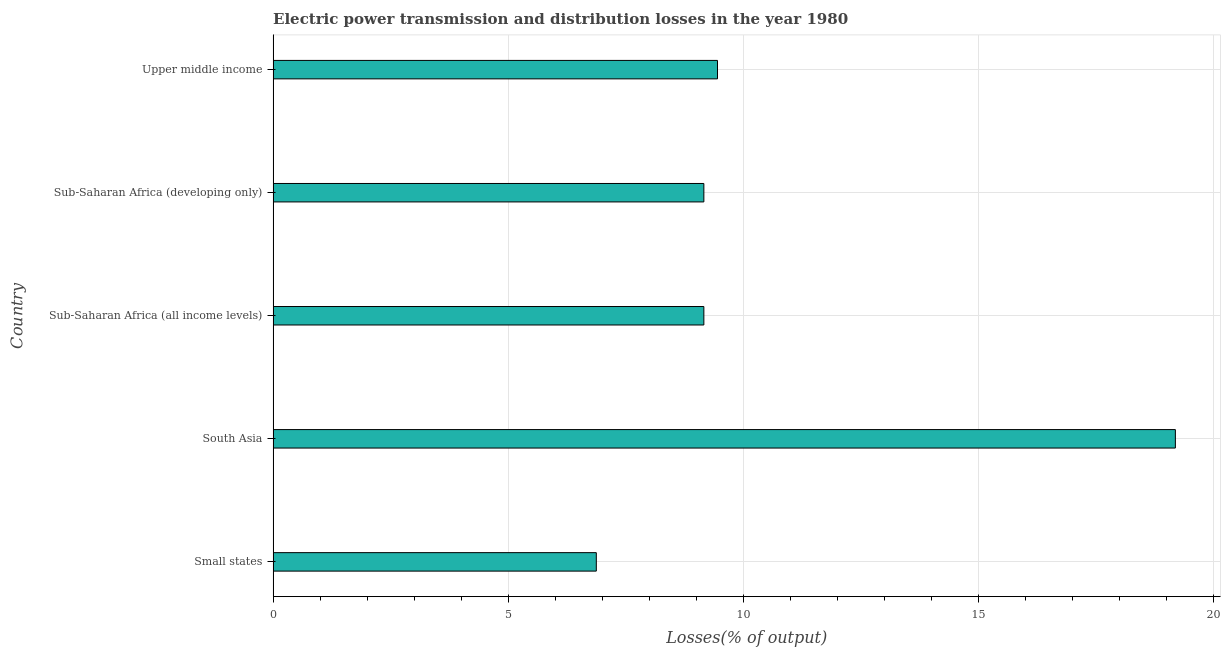Does the graph contain grids?
Ensure brevity in your answer.  Yes. What is the title of the graph?
Offer a terse response. Electric power transmission and distribution losses in the year 1980. What is the label or title of the X-axis?
Ensure brevity in your answer.  Losses(% of output). What is the label or title of the Y-axis?
Provide a succinct answer. Country. What is the electric power transmission and distribution losses in South Asia?
Ensure brevity in your answer.  19.19. Across all countries, what is the maximum electric power transmission and distribution losses?
Your answer should be compact. 19.19. Across all countries, what is the minimum electric power transmission and distribution losses?
Your answer should be compact. 6.88. In which country was the electric power transmission and distribution losses minimum?
Keep it short and to the point. Small states. What is the sum of the electric power transmission and distribution losses?
Keep it short and to the point. 53.85. What is the difference between the electric power transmission and distribution losses in Sub-Saharan Africa (developing only) and Upper middle income?
Ensure brevity in your answer.  -0.29. What is the average electric power transmission and distribution losses per country?
Provide a short and direct response. 10.77. What is the median electric power transmission and distribution losses?
Your answer should be very brief. 9.16. What is the difference between the highest and the second highest electric power transmission and distribution losses?
Your answer should be compact. 9.74. Is the sum of the electric power transmission and distribution losses in Small states and Sub-Saharan Africa (developing only) greater than the maximum electric power transmission and distribution losses across all countries?
Provide a succinct answer. No. What is the difference between the highest and the lowest electric power transmission and distribution losses?
Provide a short and direct response. 12.32. What is the Losses(% of output) in Small states?
Your answer should be compact. 6.88. What is the Losses(% of output) in South Asia?
Ensure brevity in your answer.  19.19. What is the Losses(% of output) of Sub-Saharan Africa (all income levels)?
Provide a short and direct response. 9.16. What is the Losses(% of output) of Sub-Saharan Africa (developing only)?
Your response must be concise. 9.16. What is the Losses(% of output) of Upper middle income?
Your answer should be very brief. 9.45. What is the difference between the Losses(% of output) in Small states and South Asia?
Your answer should be very brief. -12.32. What is the difference between the Losses(% of output) in Small states and Sub-Saharan Africa (all income levels)?
Your response must be concise. -2.29. What is the difference between the Losses(% of output) in Small states and Sub-Saharan Africa (developing only)?
Provide a short and direct response. -2.29. What is the difference between the Losses(% of output) in Small states and Upper middle income?
Your answer should be very brief. -2.58. What is the difference between the Losses(% of output) in South Asia and Sub-Saharan Africa (all income levels)?
Offer a terse response. 10.03. What is the difference between the Losses(% of output) in South Asia and Sub-Saharan Africa (developing only)?
Keep it short and to the point. 10.03. What is the difference between the Losses(% of output) in South Asia and Upper middle income?
Provide a short and direct response. 9.74. What is the difference between the Losses(% of output) in Sub-Saharan Africa (all income levels) and Sub-Saharan Africa (developing only)?
Ensure brevity in your answer.  0. What is the difference between the Losses(% of output) in Sub-Saharan Africa (all income levels) and Upper middle income?
Keep it short and to the point. -0.29. What is the difference between the Losses(% of output) in Sub-Saharan Africa (developing only) and Upper middle income?
Make the answer very short. -0.29. What is the ratio of the Losses(% of output) in Small states to that in South Asia?
Give a very brief answer. 0.36. What is the ratio of the Losses(% of output) in Small states to that in Sub-Saharan Africa (all income levels)?
Keep it short and to the point. 0.75. What is the ratio of the Losses(% of output) in Small states to that in Upper middle income?
Provide a succinct answer. 0.73. What is the ratio of the Losses(% of output) in South Asia to that in Sub-Saharan Africa (all income levels)?
Offer a terse response. 2.1. What is the ratio of the Losses(% of output) in South Asia to that in Sub-Saharan Africa (developing only)?
Offer a very short reply. 2.1. What is the ratio of the Losses(% of output) in South Asia to that in Upper middle income?
Offer a very short reply. 2.03. 